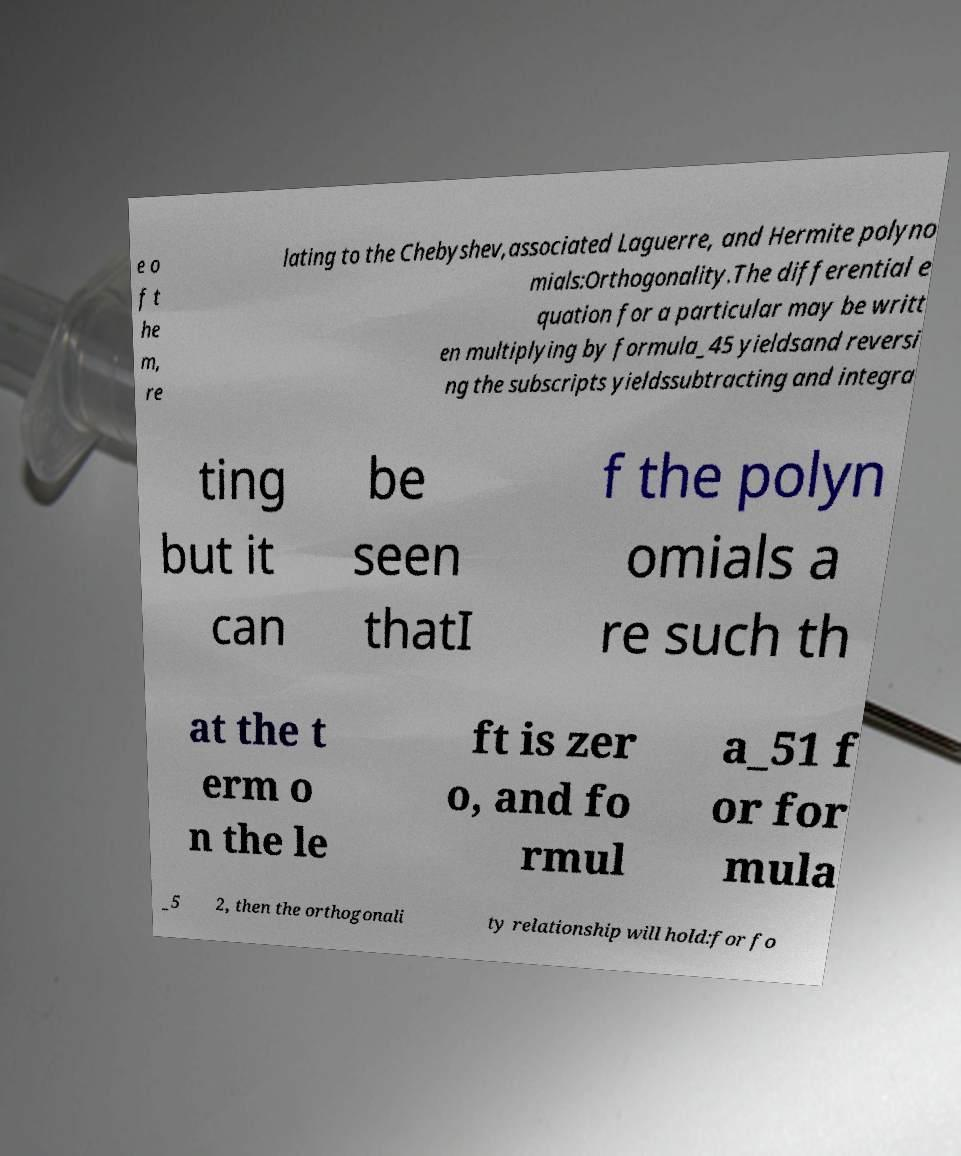Please identify and transcribe the text found in this image. e o f t he m, re lating to the Chebyshev,associated Laguerre, and Hermite polyno mials:Orthogonality.The differential e quation for a particular may be writt en multiplying by formula_45 yieldsand reversi ng the subscripts yieldssubtracting and integra ting but it can be seen thatI f the polyn omials a re such th at the t erm o n the le ft is zer o, and fo rmul a_51 f or for mula _5 2, then the orthogonali ty relationship will hold:for fo 